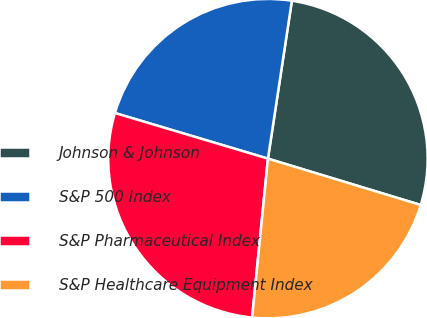<chart> <loc_0><loc_0><loc_500><loc_500><pie_chart><fcel>Johnson & Johnson<fcel>S&P 500 Index<fcel>S&P Pharmaceutical Index<fcel>S&P Healthcare Equipment Index<nl><fcel>27.29%<fcel>22.78%<fcel>28.03%<fcel>21.89%<nl></chart> 